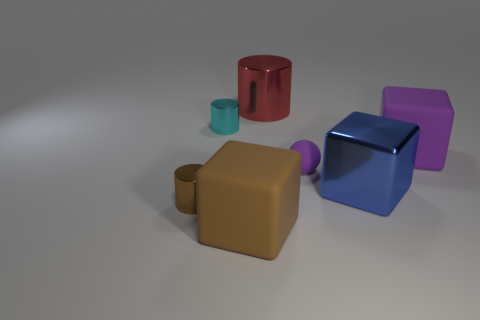Add 1 rubber blocks. How many objects exist? 8 Subtract all cubes. How many objects are left? 4 Add 5 tiny cyan shiny cylinders. How many tiny cyan shiny cylinders are left? 6 Add 5 purple blocks. How many purple blocks exist? 6 Subtract 0 cyan balls. How many objects are left? 7 Subtract all metal cylinders. Subtract all big things. How many objects are left? 0 